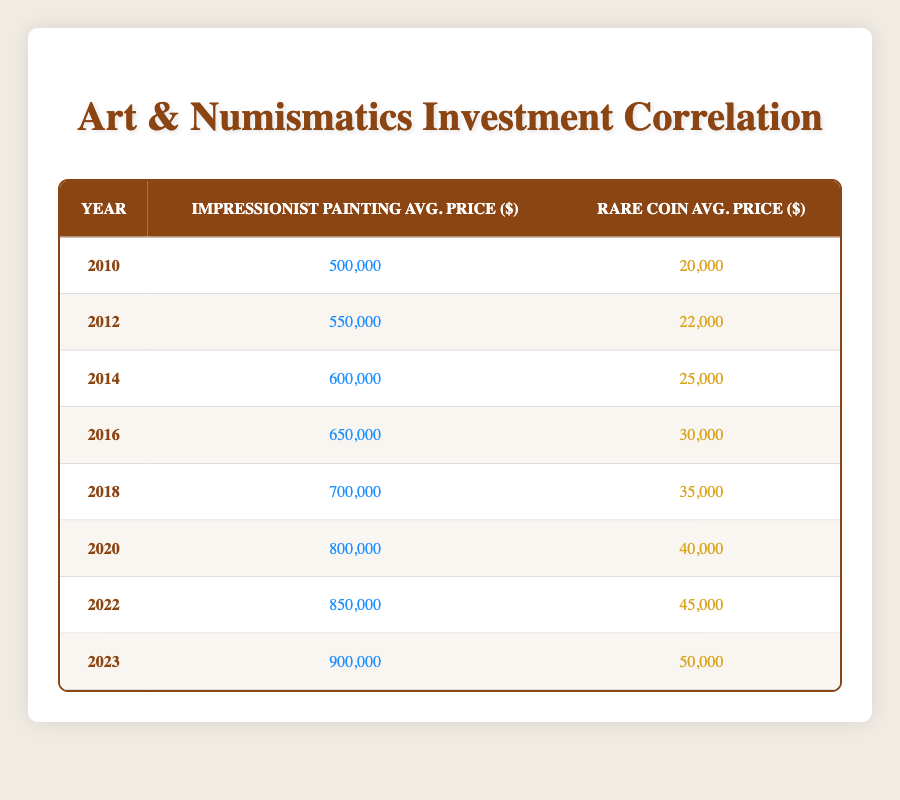What was the average price of impressionist paintings in 2020? In the table, under the year 2020, the average price of impressionist paintings is listed as 800,000.
Answer: 800,000 What was the average price of rare coins in 2012? The table shows that in 2012, the average price of rare coins was 22,000.
Answer: 22,000 What is the difference in average prices of impressionist paintings between 2010 and 2023? The average price in 2010 was 500,000 and in 2023 it was 900,000. The difference is 900,000 - 500,000 = 400,000.
Answer: 400,000 Is the average price of rare coins higher in 2020 than in 2016? In 2020, the average price of rare coins was 40,000, and in 2016 it was 30,000. Since 40,000 is greater than 30,000, the statement is true.
Answer: Yes Which category saw a greater increase in average price from 2014 to 2022? The average price of impressionist paintings increased from 600,000 in 2014 to 850,000 in 2022, a difference of 250,000. For rare coins, the price increased from 25,000 in 2014 to 45,000 in 2022, a difference of 20,000. Since 250,000 > 20,000, impressionist paintings saw the greater increase.
Answer: Impressionist paintings What is the average price of rare coins for the years 2016 and 2022? For 2016, the average price is 30,000 and for 2022 it is 45,000. Adding these gives 30,000 + 45,000 = 75,000, and dividing by the two years (75,000/2) gives an average of 37,500.
Answer: 37,500 Was the average price of impressionist paintings in 2018 lower than in 2016? In the table, impressionist paintings were priced at 700,000 in 2018 and 650,000 in 2016. Since 700,000 is greater than 650,000, the statement is false.
Answer: No What is the total average price of impressionist paintings from 2010 to 2023? The prices are 500,000 (2010), 550,000 (2012), 600,000 (2014), 650,000 (2016), 700,000 (2018), 800,000 (2020), 850,000 (2022), and 900,000 (2023). Summing these gives 500,000 + 550,000 + 600,000 + 650,000 + 700,000 + 800,000 + 850,000 + 900,000 = 4,650,000.
Answer: 4,650,000 